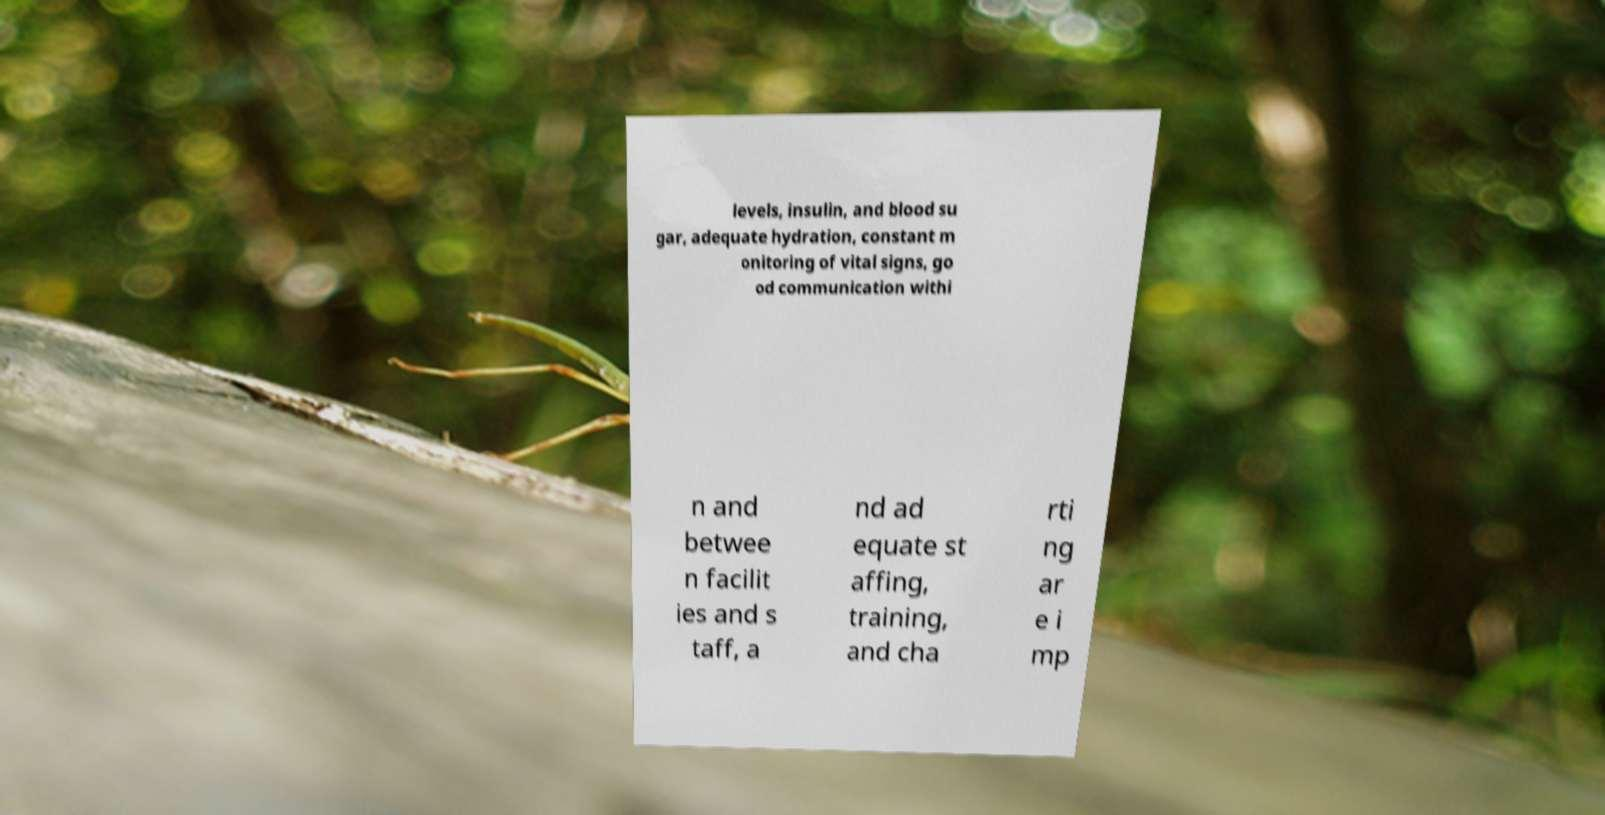Please identify and transcribe the text found in this image. levels, insulin, and blood su gar, adequate hydration, constant m onitoring of vital signs, go od communication withi n and betwee n facilit ies and s taff, a nd ad equate st affing, training, and cha rti ng ar e i mp 